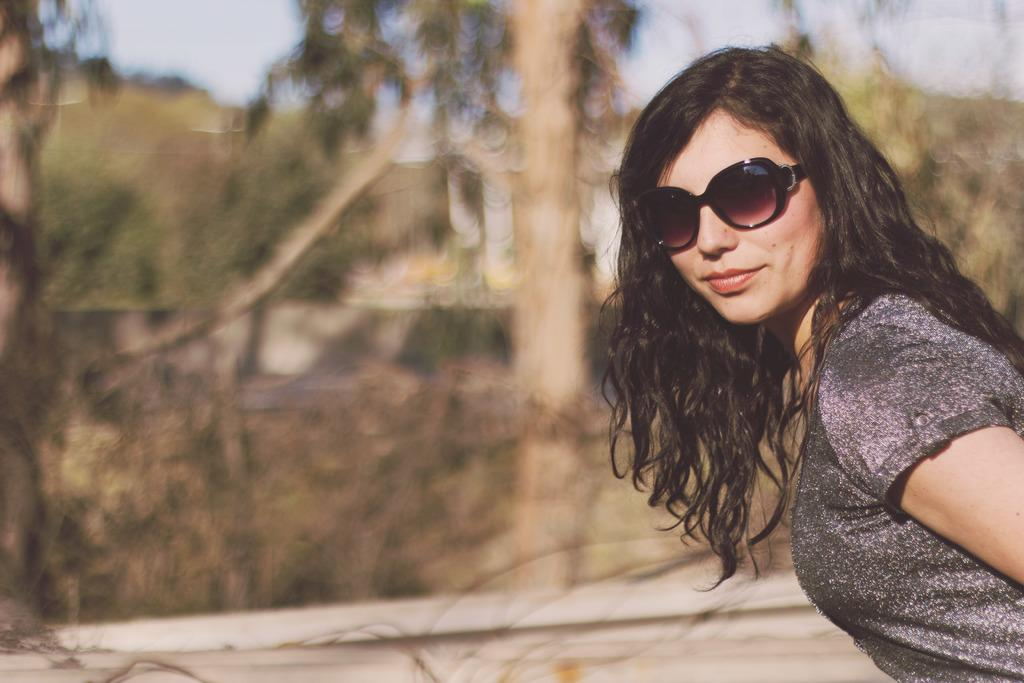Who is present in the image? There is a woman in the image. What is the woman wearing on her face? The woman is wearing goggles. Where is the woman located in the image? The woman is in the right corner of the image. What can be seen in the background of the image? There are trees in the background of the image. What type of food is the woman holding in the image? There is no food visible in the image; the woman is wearing goggles and standing in the right corner of the image. 